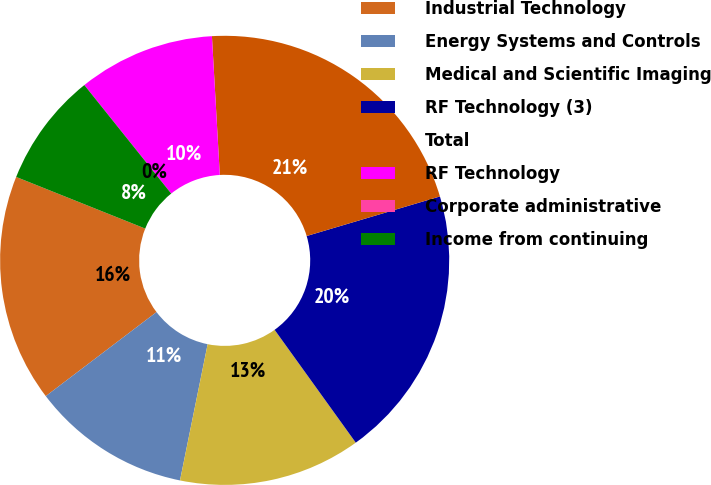Convert chart. <chart><loc_0><loc_0><loc_500><loc_500><pie_chart><fcel>Industrial Technology<fcel>Energy Systems and Controls<fcel>Medical and Scientific Imaging<fcel>RF Technology (3)<fcel>Total<fcel>RF Technology<fcel>Corporate administrative<fcel>Income from continuing<nl><fcel>16.39%<fcel>11.48%<fcel>13.11%<fcel>19.67%<fcel>21.31%<fcel>9.84%<fcel>0.0%<fcel>8.2%<nl></chart> 